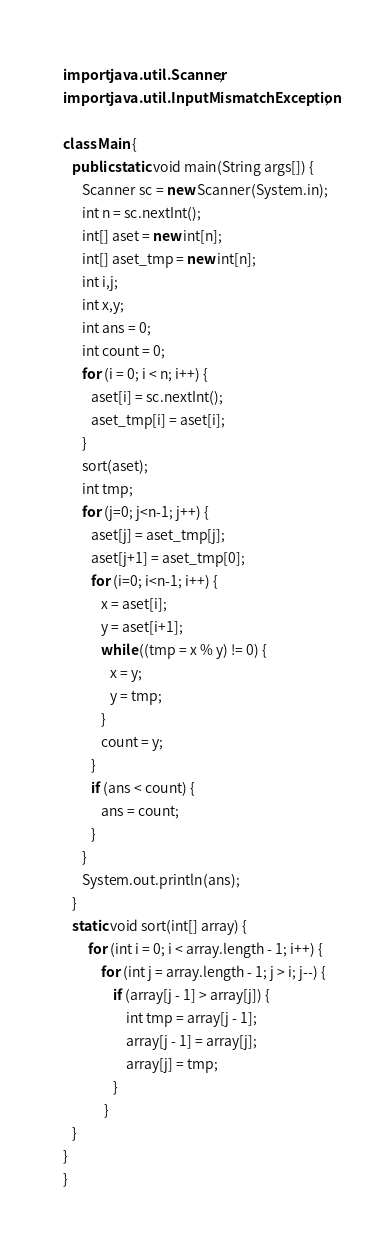Convert code to text. <code><loc_0><loc_0><loc_500><loc_500><_Java_>import java.util.Scanner;
import java.util.InputMismatchException;

class Main {
   public static void main(String args[]) {
      Scanner sc = new Scanner(System.in);
      int n = sc.nextInt();
      int[] aset = new int[n];
      int[] aset_tmp = new int[n];
      int i,j;
      int x,y;
      int ans = 0;
      int count = 0;
      for (i = 0; i < n; i++) {
         aset[i] = sc.nextInt();
         aset_tmp[i] = aset[i];
      }
      sort(aset);
      int tmp;
      for (j=0; j<n-1; j++) {
         aset[j] = aset_tmp[j];
         aset[j+1] = aset_tmp[0];
         for (i=0; i<n-1; i++) {
            x = aset[i];
            y = aset[i+1];
            while ((tmp = x % y) != 0) {
               x = y;
               y = tmp;
            }
            count = y;
         }
         if (ans < count) {
            ans = count;
         }
      }
      System.out.println(ans);
   }
   static void sort(int[] array) {
        for (int i = 0; i < array.length - 1; i++) {
            for (int j = array.length - 1; j > i; j--) {
                if (array[j - 1] > array[j]) {
                    int tmp = array[j - 1];
                    array[j - 1] = array[j];
                    array[j] = tmp;
                }
             }
   }
}
}
</code> 